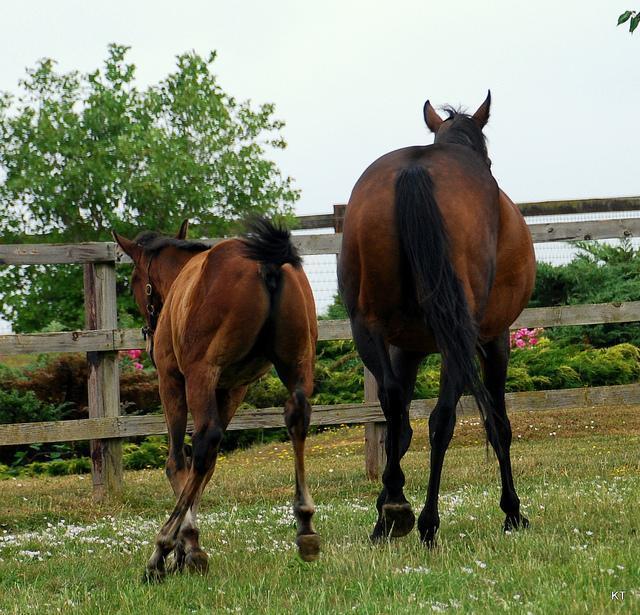How many horses?
Give a very brief answer. 2. How many horses are there?
Give a very brief answer. 2. 